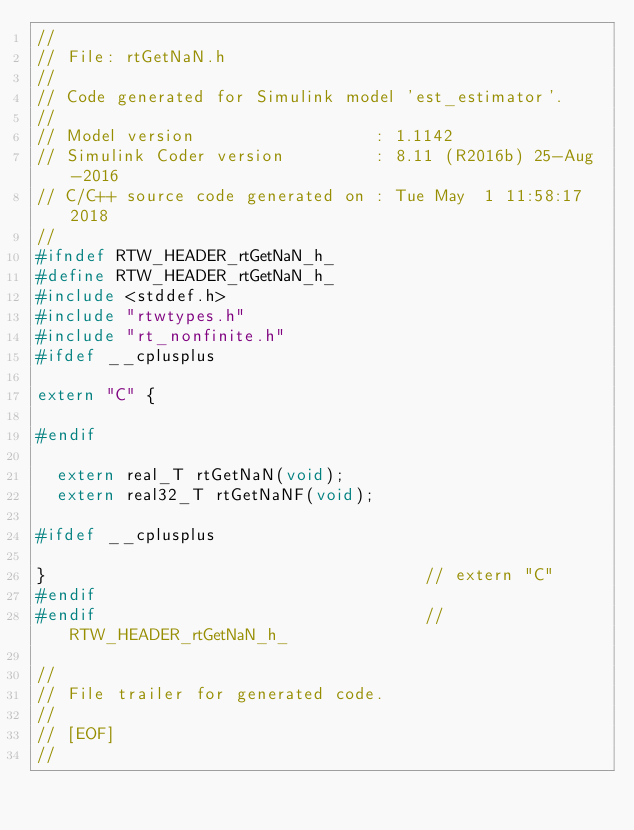Convert code to text. <code><loc_0><loc_0><loc_500><loc_500><_C_>//
// File: rtGetNaN.h
//
// Code generated for Simulink model 'est_estimator'.
//
// Model version                  : 1.1142
// Simulink Coder version         : 8.11 (R2016b) 25-Aug-2016
// C/C++ source code generated on : Tue May  1 11:58:17 2018
//
#ifndef RTW_HEADER_rtGetNaN_h_
#define RTW_HEADER_rtGetNaN_h_
#include <stddef.h>
#include "rtwtypes.h"
#include "rt_nonfinite.h"
#ifdef __cplusplus

extern "C" {

#endif

  extern real_T rtGetNaN(void);
  extern real32_T rtGetNaNF(void);

#ifdef __cplusplus

}                                      // extern "C"
#endif
#endif                                 // RTW_HEADER_rtGetNaN_h_

//
// File trailer for generated code.
//
// [EOF]
//
</code> 